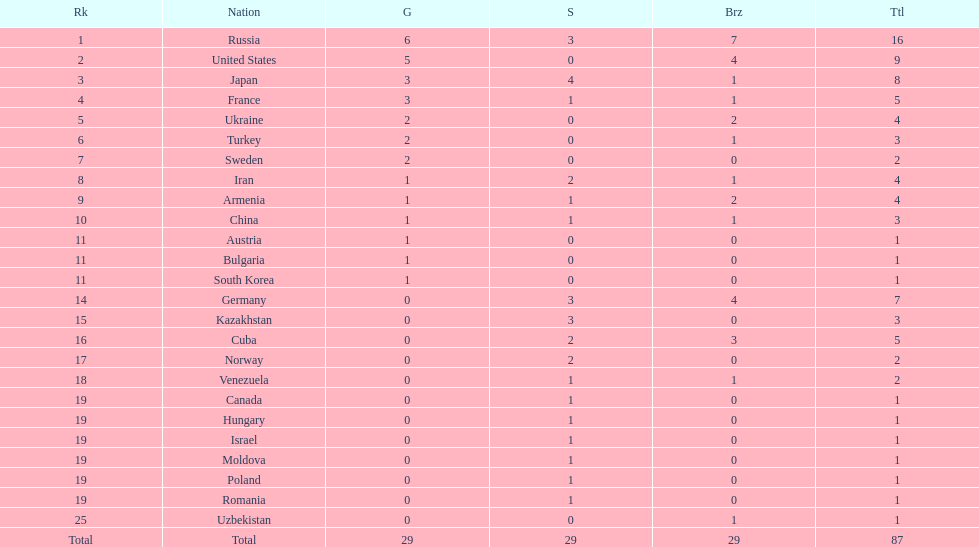In which country was only one medal, a bronze, won? Uzbekistan. Parse the table in full. {'header': ['Rk', 'Nation', 'G', 'S', 'Brz', 'Ttl'], 'rows': [['1', 'Russia', '6', '3', '7', '16'], ['2', 'United States', '5', '0', '4', '9'], ['3', 'Japan', '3', '4', '1', '8'], ['4', 'France', '3', '1', '1', '5'], ['5', 'Ukraine', '2', '0', '2', '4'], ['6', 'Turkey', '2', '0', '1', '3'], ['7', 'Sweden', '2', '0', '0', '2'], ['8', 'Iran', '1', '2', '1', '4'], ['9', 'Armenia', '1', '1', '2', '4'], ['10', 'China', '1', '1', '1', '3'], ['11', 'Austria', '1', '0', '0', '1'], ['11', 'Bulgaria', '1', '0', '0', '1'], ['11', 'South Korea', '1', '0', '0', '1'], ['14', 'Germany', '0', '3', '4', '7'], ['15', 'Kazakhstan', '0', '3', '0', '3'], ['16', 'Cuba', '0', '2', '3', '5'], ['17', 'Norway', '0', '2', '0', '2'], ['18', 'Venezuela', '0', '1', '1', '2'], ['19', 'Canada', '0', '1', '0', '1'], ['19', 'Hungary', '0', '1', '0', '1'], ['19', 'Israel', '0', '1', '0', '1'], ['19', 'Moldova', '0', '1', '0', '1'], ['19', 'Poland', '0', '1', '0', '1'], ['19', 'Romania', '0', '1', '0', '1'], ['25', 'Uzbekistan', '0', '0', '1', '1'], ['Total', 'Total', '29', '29', '29', '87']]} 